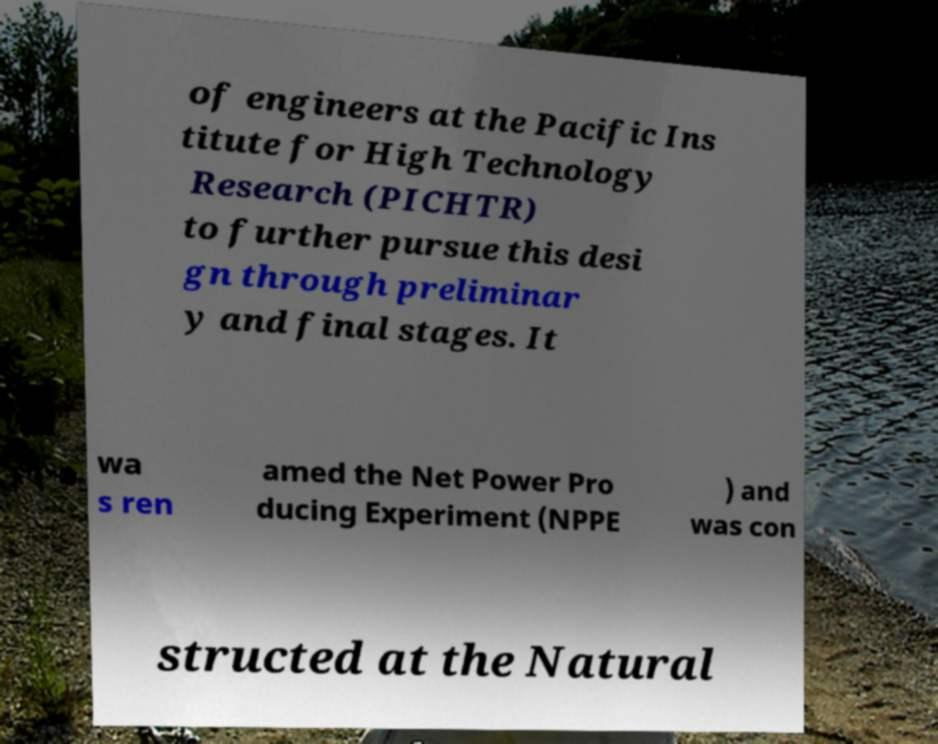Can you read and provide the text displayed in the image?This photo seems to have some interesting text. Can you extract and type it out for me? of engineers at the Pacific Ins titute for High Technology Research (PICHTR) to further pursue this desi gn through preliminar y and final stages. It wa s ren amed the Net Power Pro ducing Experiment (NPPE ) and was con structed at the Natural 